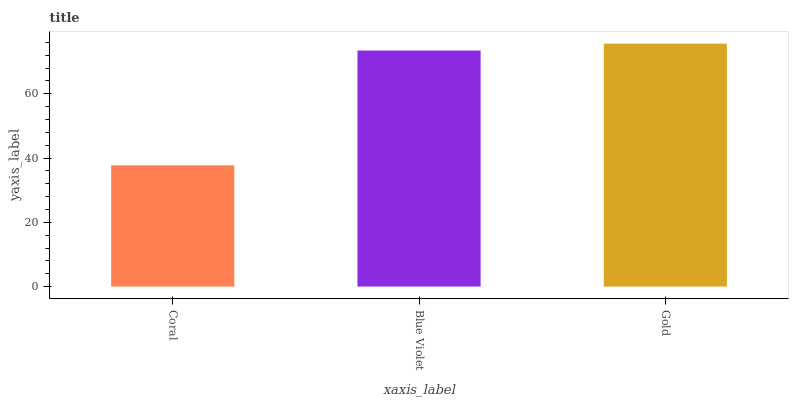Is Coral the minimum?
Answer yes or no. Yes. Is Gold the maximum?
Answer yes or no. Yes. Is Blue Violet the minimum?
Answer yes or no. No. Is Blue Violet the maximum?
Answer yes or no. No. Is Blue Violet greater than Coral?
Answer yes or no. Yes. Is Coral less than Blue Violet?
Answer yes or no. Yes. Is Coral greater than Blue Violet?
Answer yes or no. No. Is Blue Violet less than Coral?
Answer yes or no. No. Is Blue Violet the high median?
Answer yes or no. Yes. Is Blue Violet the low median?
Answer yes or no. Yes. Is Gold the high median?
Answer yes or no. No. Is Coral the low median?
Answer yes or no. No. 